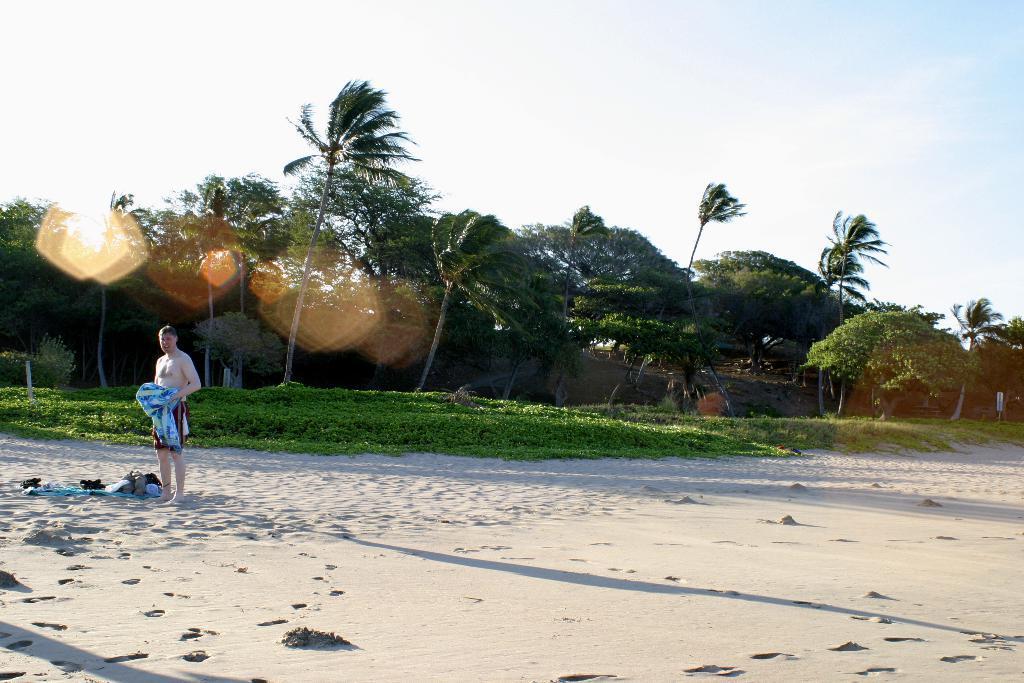Could you give a brief overview of what you see in this image? In this image, there are a few trees, plants. We can see the ground with sand and a few objects. We can also see a person holding some object. We can also see an object on the right. We can see the sky. 